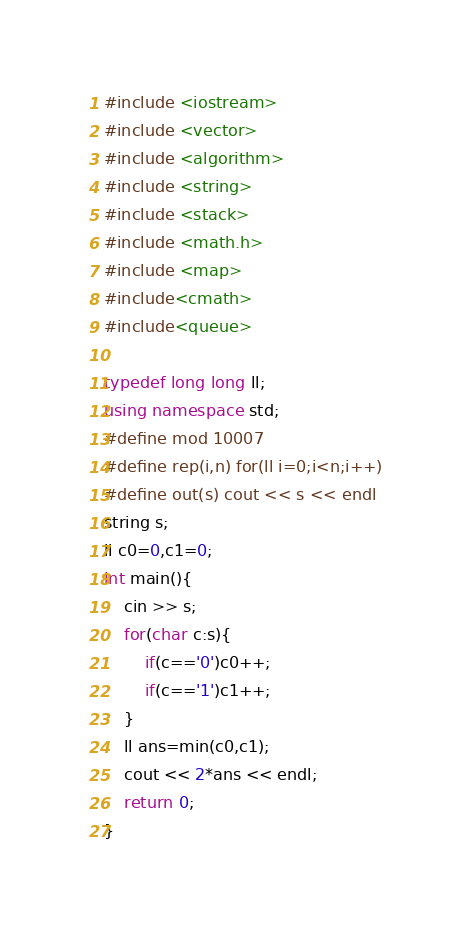<code> <loc_0><loc_0><loc_500><loc_500><_C++_>#include <iostream>
#include <vector>
#include <algorithm>
#include <string>
#include <stack>
#include <math.h>
#include <map>
#include<cmath>
#include<queue>

typedef long long ll;
using namespace std;
#define mod 10007
#define rep(i,n) for(ll i=0;i<n;i++)
#define out(s) cout << s << endl
string s;
ll c0=0,c1=0;
int main(){
    cin >> s;
    for(char c:s){
        if(c=='0')c0++;
        if(c=='1')c1++;
    }
    ll ans=min(c0,c1);
    cout << 2*ans << endl;
    return 0;
}
</code> 